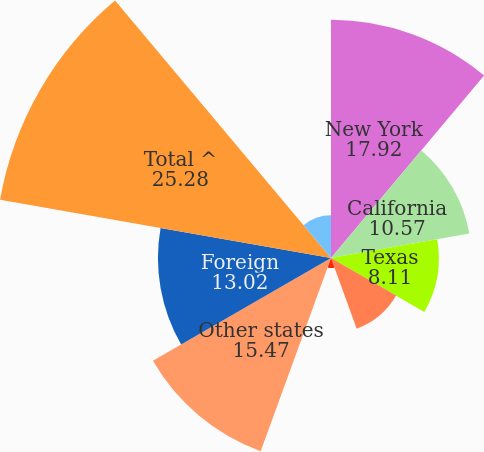Convert chart. <chart><loc_0><loc_0><loc_500><loc_500><pie_chart><fcel>New York<fcel>California<fcel>Texas<fcel>Florida<fcel>Illinois<fcel>Other states<fcel>Foreign<fcel>Total ^<fcel>Pennsylvania<nl><fcel>17.92%<fcel>10.57%<fcel>8.11%<fcel>5.66%<fcel>0.76%<fcel>15.47%<fcel>13.02%<fcel>25.28%<fcel>3.21%<nl></chart> 